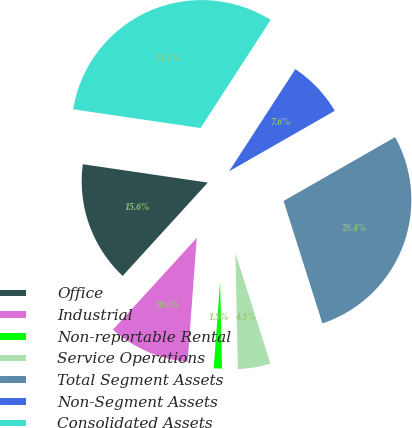Convert chart. <chart><loc_0><loc_0><loc_500><loc_500><pie_chart><fcel>Office<fcel>Industrial<fcel>Non-reportable Rental<fcel>Service Operations<fcel>Total Segment Assets<fcel>Non-Segment Assets<fcel>Consolidated Assets<nl><fcel>15.55%<fcel>10.6%<fcel>1.51%<fcel>4.54%<fcel>28.39%<fcel>7.57%<fcel>31.83%<nl></chart> 